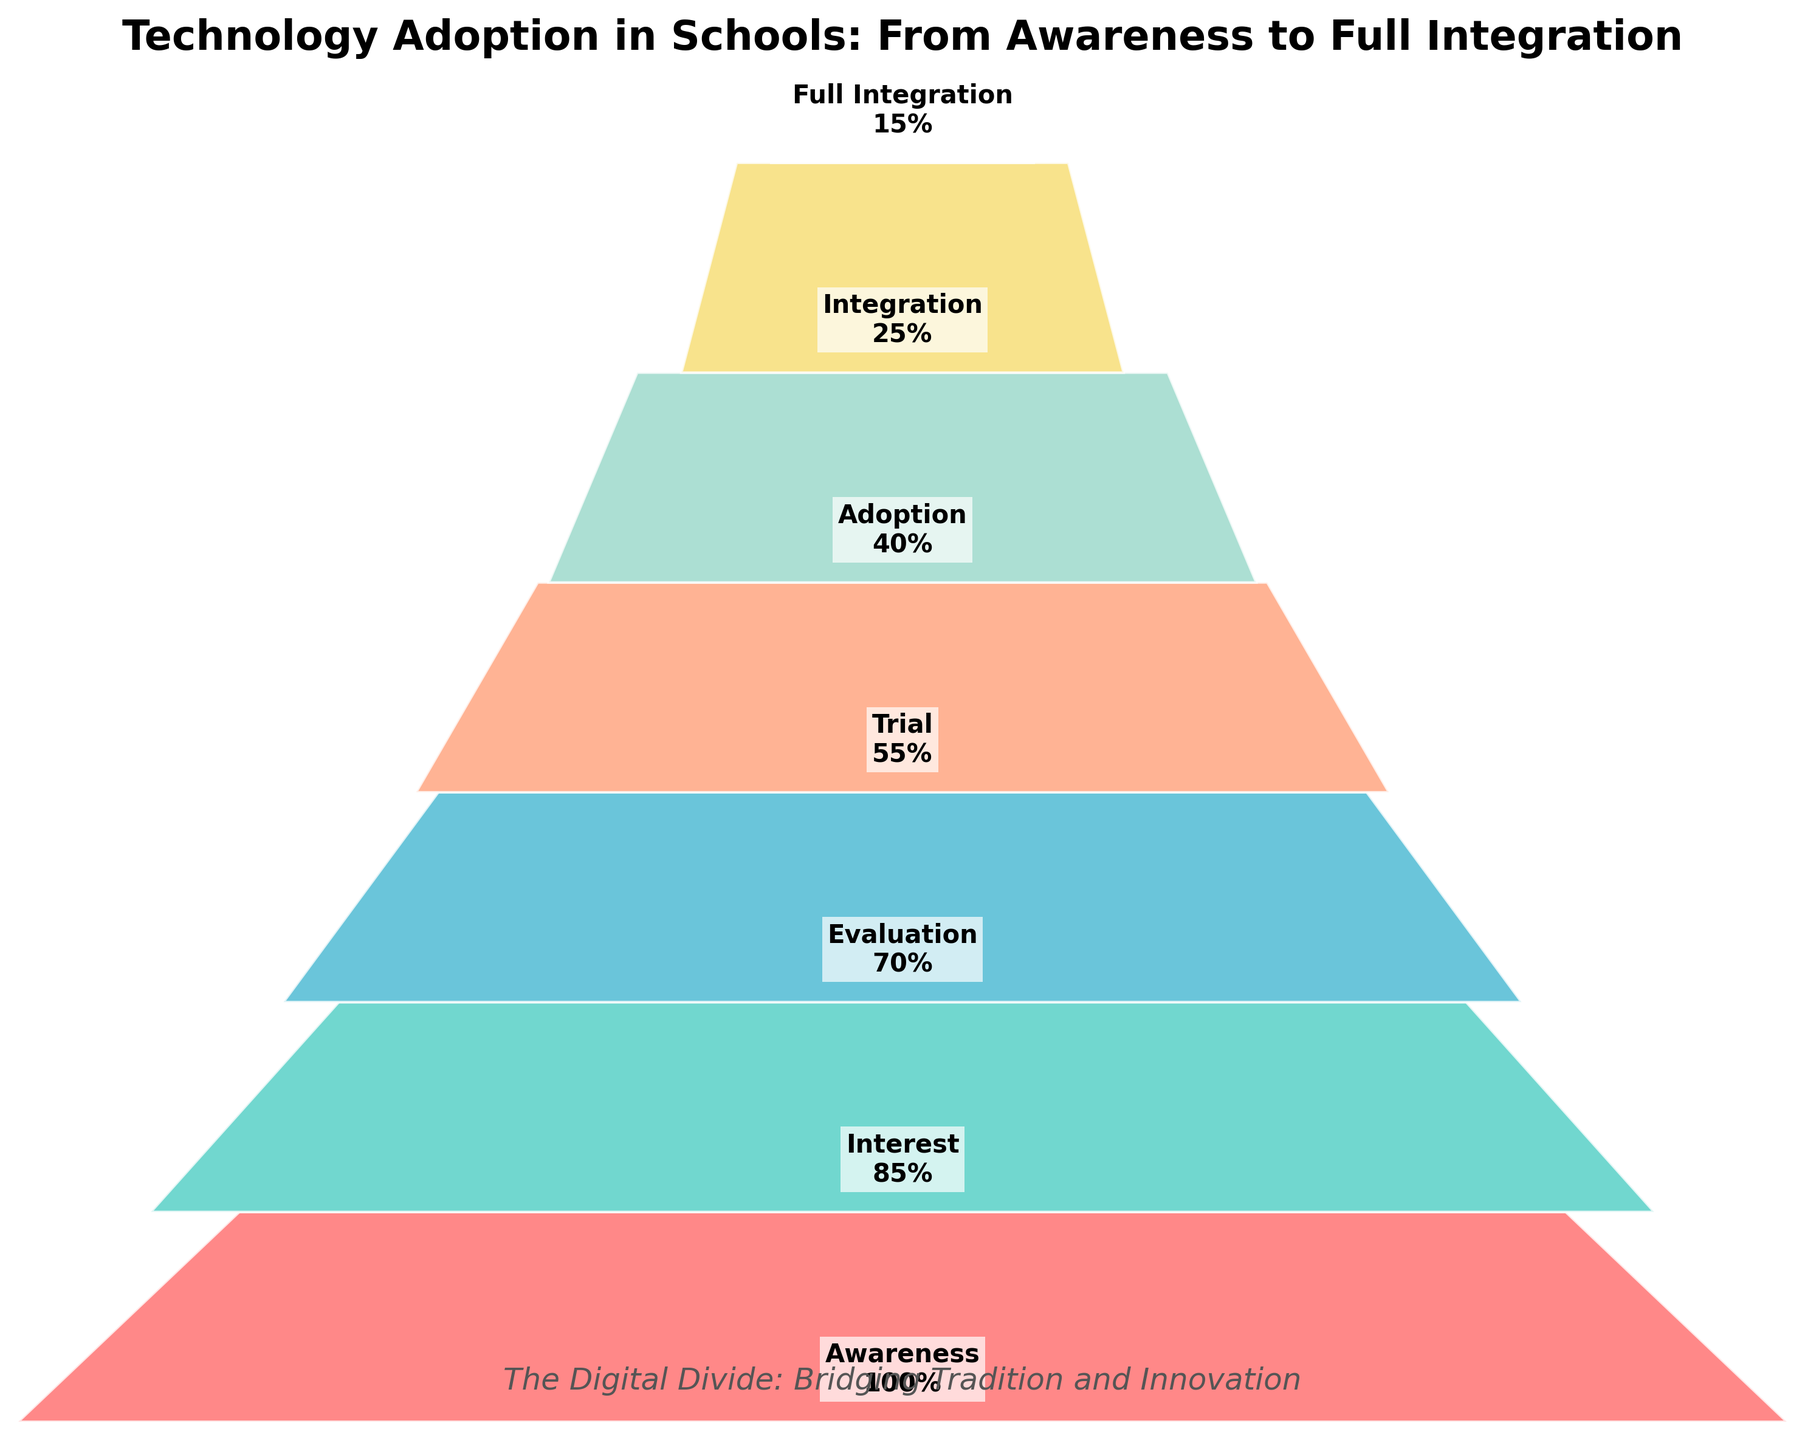What's the title of the funnel chart? To determine the title, look at the top of the funnel chart where the main heading is usually displayed.
Answer: Technology Adoption in Schools: From Awareness to Full Integration What is the first stage in the funnel? The first stage is usually at the widest part of the funnel, representing the largest percentage.
Answer: Awareness What is the percentage for the 'Trial' stage? Locate the 'Trial' stage on the chart and refer to the percentage shown next to it.
Answer: 55% Which stage has the lowest percentage? Find the narrowest part of the funnel, which represents the smallest percentage.
Answer: Full Integration By what percentage does 'Interest' decrease from 'Awareness'? Subtract the percentage of 'Interest' from 'Awareness'. Specifically, 100% (Awareness) - 85% (Interest).
Answer: 15% What is the sum of the percentages for 'Evaluation' and 'Trial'? Add the percentages: 70% (Evaluation) + 55% (Trial).
Answer: 125% How much smaller is the 'Integration' percentage compared to 'Adoption'? Subtract 'Integration' percentage from 'Adoption' percentage: 40% (Adoption) - 25% (Integration).
Answer: 15% Is 'Evaluation' percentage greater than 'Adoption' percentage? Compare the percentages of 'Evaluation' (70%) and 'Adoption' (40%).
Answer: Yes How do the colors change as you move from 'Awareness' to 'Full Integration'? Identify the colors used for each stage and observe the transition in shades. Initially, it starts with warmer colors and gradually transitions into cooler colors towards the bottom.
Answer: Warmer to cooler colors What is the difference in percentage between 'Interest' and 'Full Integration'? Subtract the percentage of 'Full Integration' from 'Interest': 85% (Interest) - 15% (Full Integration).
Answer: 70% In which stage does the funnel transition from more than half to less than half of the maximum percentage? Identify the stage where the percentages go from greater than 50% to less than 50%. This happens between 'Trial' (55%) and 'Adoption' (40%).
Answer: Between Trial and Adoption 